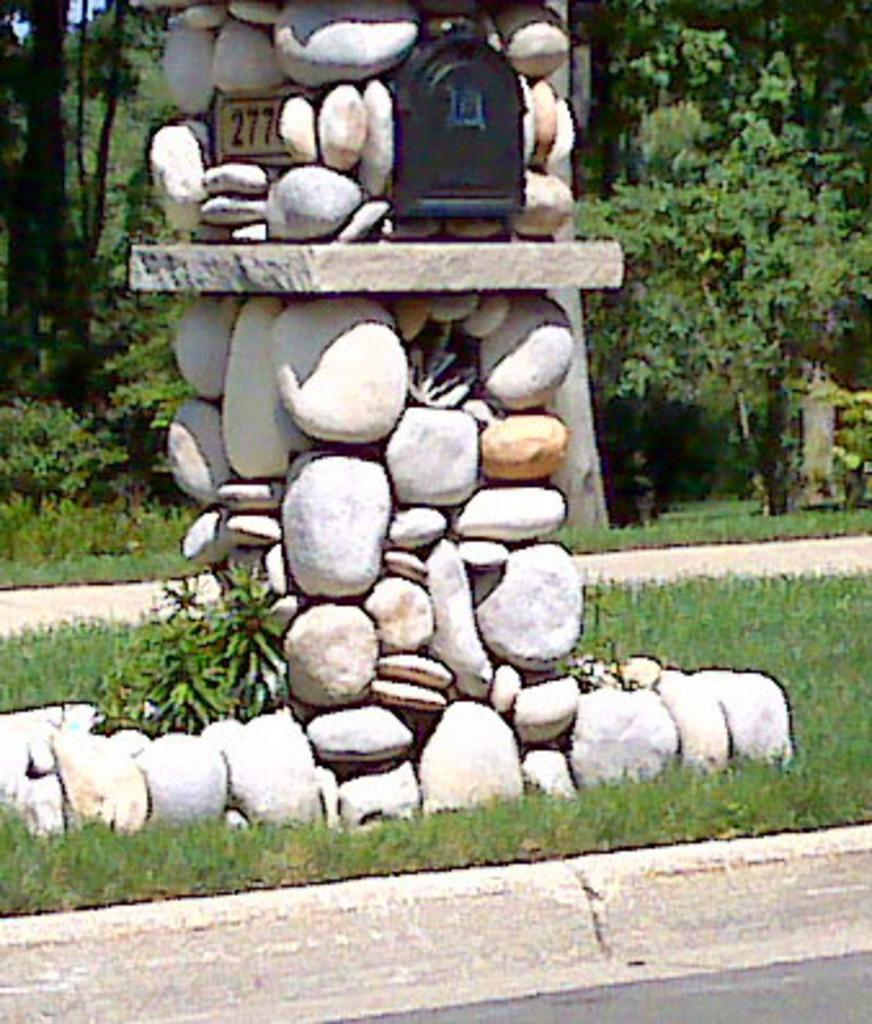Can you describe this image briefly? In this image there are a few rocks arranged, in between them there are a few objects. In the background there are trees and grass. 